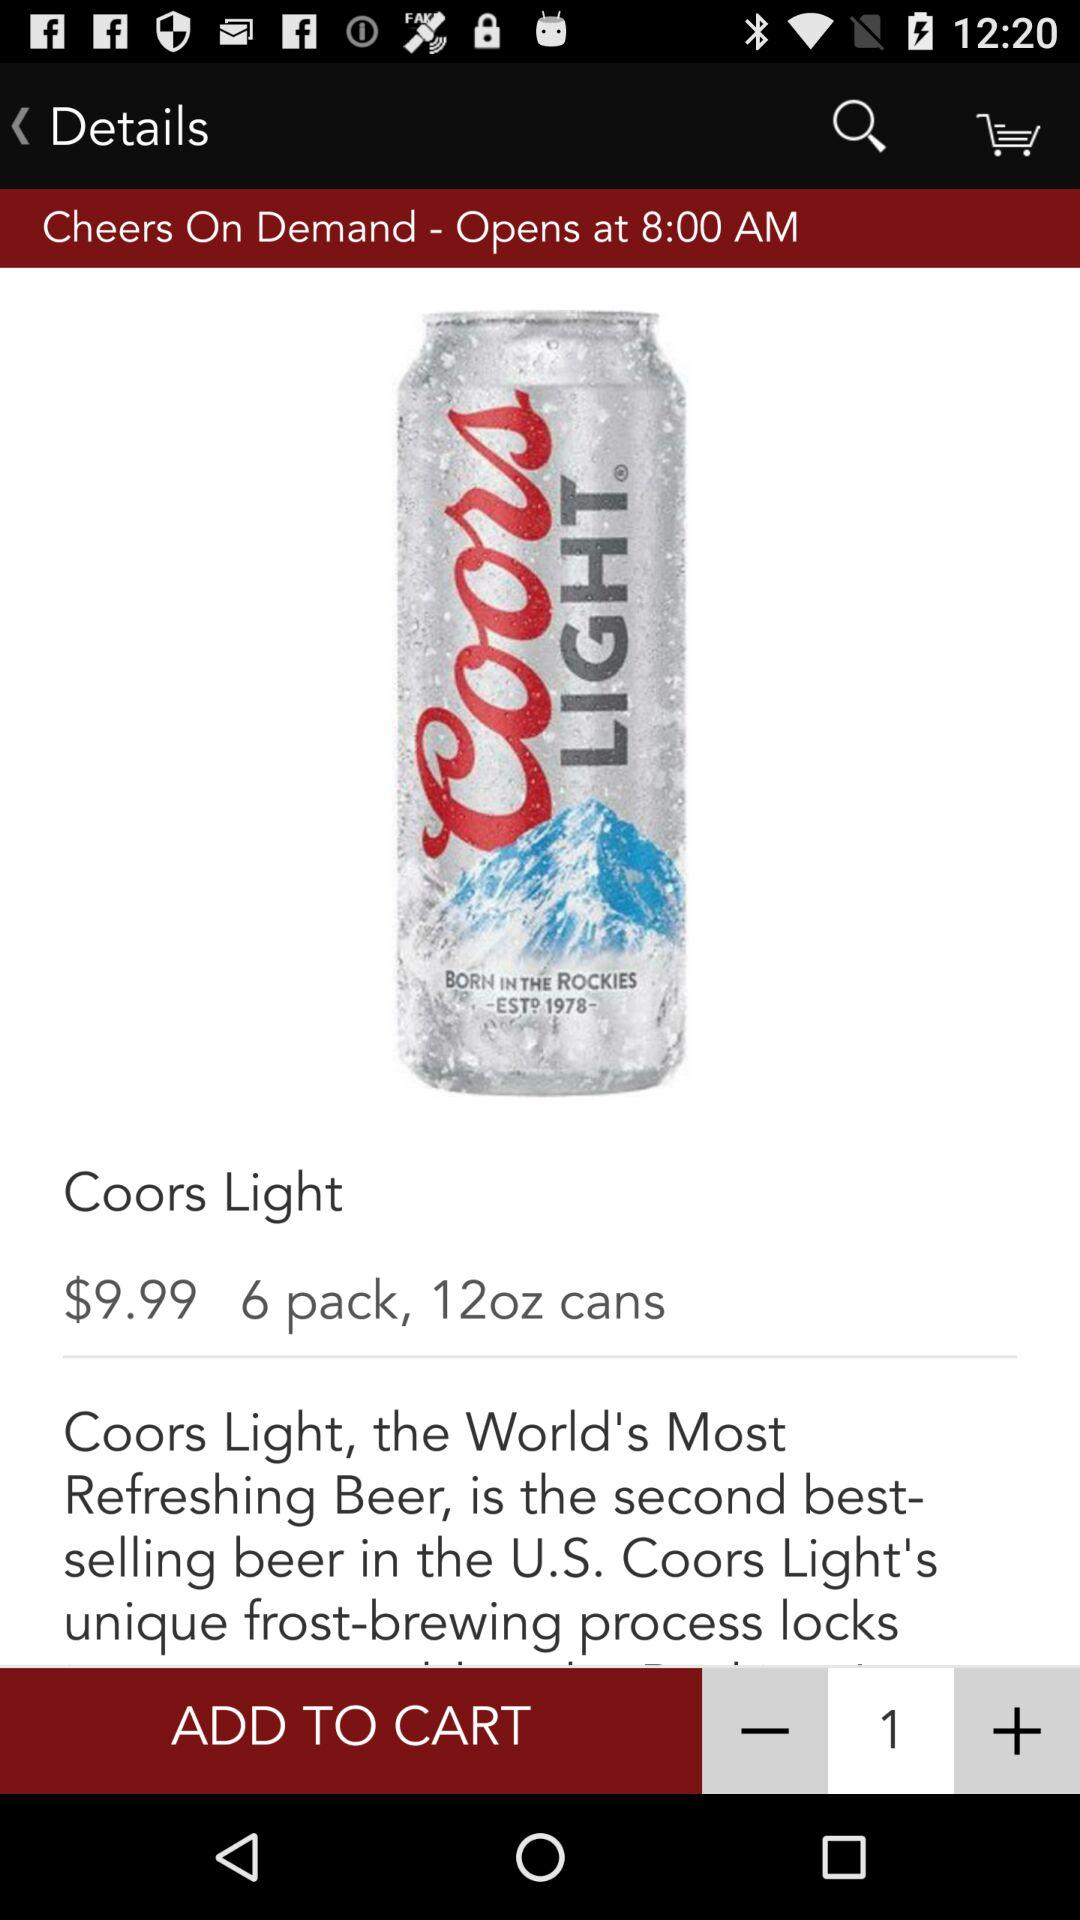What is the price for a 6-pack of "Coors Light"? The price is $9.99. 